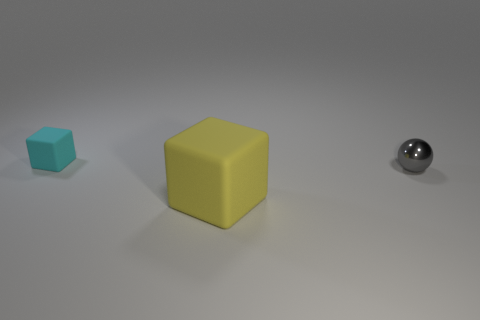Add 2 small purple rubber spheres. How many objects exist? 5 Subtract all balls. How many objects are left? 2 Subtract all big brown balls. Subtract all spheres. How many objects are left? 2 Add 3 balls. How many balls are left? 4 Add 1 cylinders. How many cylinders exist? 1 Subtract 0 purple cubes. How many objects are left? 3 